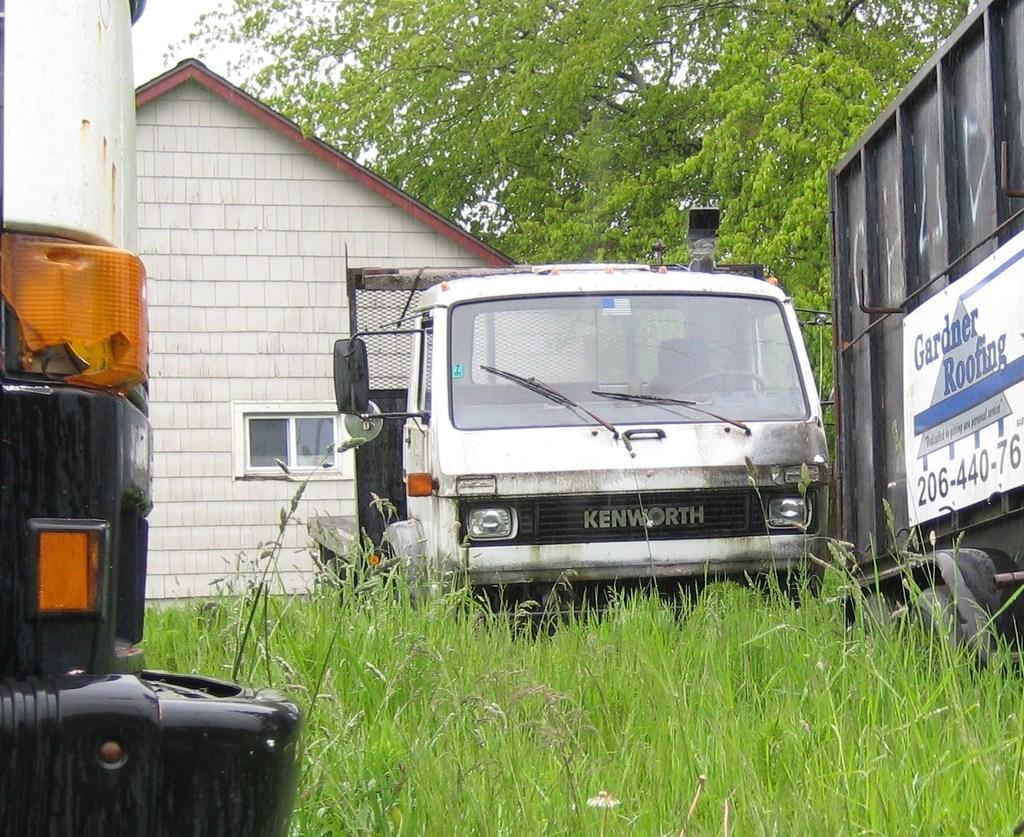What brand of truck/van is this?
Offer a very short reply. Kenworth. What is the name of the roofing company?
Provide a short and direct response. Gardner. 